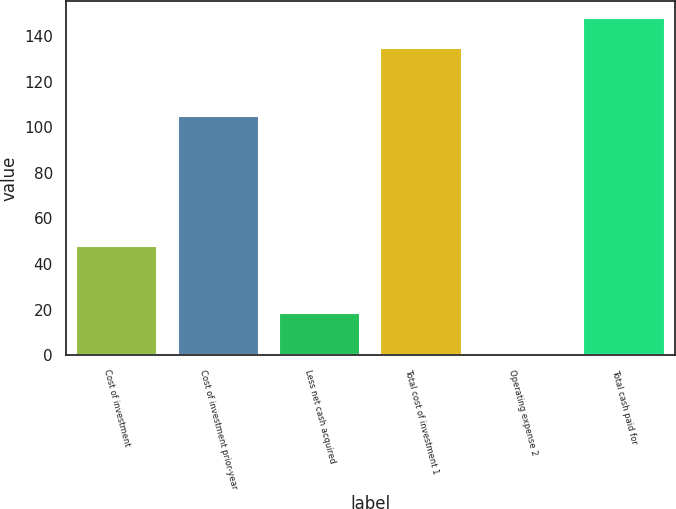<chart> <loc_0><loc_0><loc_500><loc_500><bar_chart><fcel>Cost of investment<fcel>Cost of investment prior-year<fcel>Less net cash acquired<fcel>Total cost of investment 1<fcel>Operating expense 2<fcel>Total cash paid for<nl><fcel>48<fcel>105.1<fcel>18.5<fcel>134.6<fcel>0.5<fcel>148.06<nl></chart> 